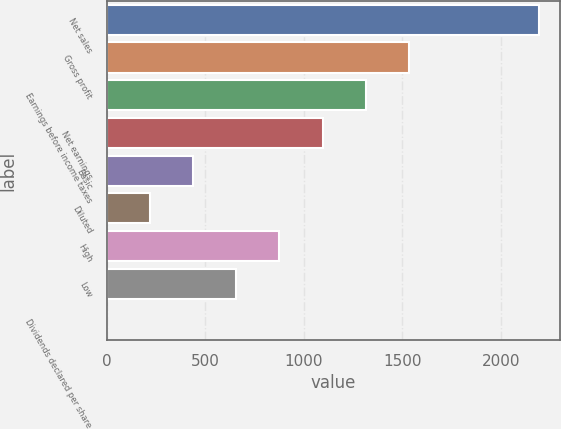<chart> <loc_0><loc_0><loc_500><loc_500><bar_chart><fcel>Net sales<fcel>Gross profit<fcel>Earnings before income taxes<fcel>Net earnings<fcel>Basic<fcel>Diluted<fcel>High<fcel>Low<fcel>Dividends declared per share<nl><fcel>2190<fcel>1533.06<fcel>1314.09<fcel>1095.12<fcel>438.21<fcel>219.24<fcel>876.15<fcel>657.18<fcel>0.27<nl></chart> 